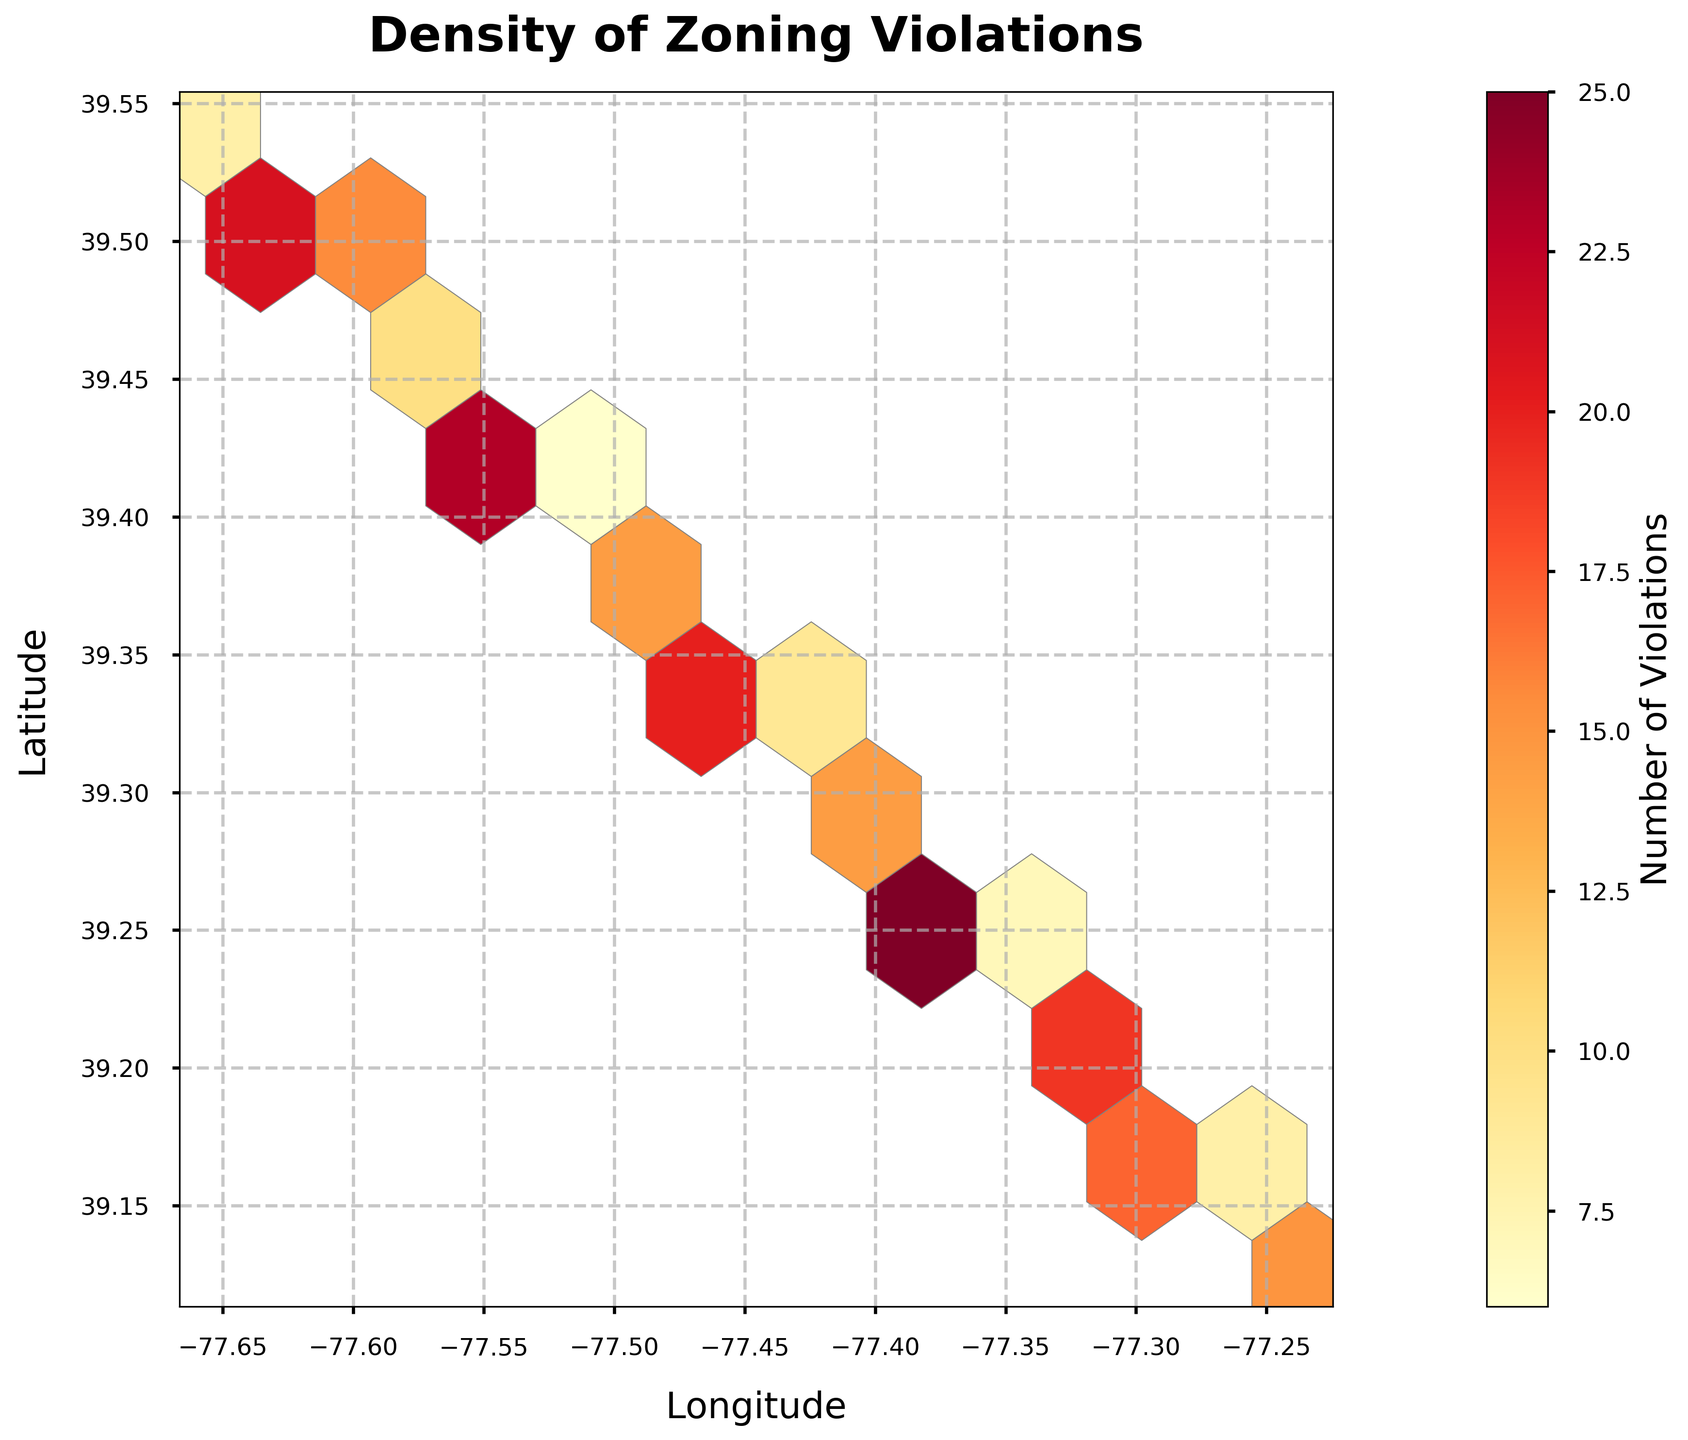What's the title of the figure? To determine the title, look at the top of the plot which typically contains this information. In this case, it states “Density of Zoning Violations”.
Answer: Density of Zoning Violations What do the colors in the hexagons represent? The color intensity in each hexagon indicates the number of zoning violations reported in a specific area. Areas with a higher density of violations will be represented with darker colors, according to the color map used, 'YlOrRd'.
Answer: Number of Violations What's the maximum density of zoning violations observed? By looking at the color bar, you can observe the correlation between color and number of violations. Identify the darkest hexagon and match it with the value on the color bar.
Answer: 25 Which coordinate has the highest number of violations? Locate the darkest hexagon on the plot, then check its corresponding coordinates (latitude and longitude). This hexagon represents the area with the highest number of violations.
Answer: (39.2556, -77.3678) What is the average number of violations in the darkest hexbin? Firstly, identify the darkest hexbin which correlates with the highest number of violations (25). Since it's a single value, the average is simply that value itself.
Answer: 25 How do the number of violations change as you move from west to east in the county? To understand the trend, observe the plot horizontally from left (west) to right (east). Note whether the color intensity increases, decreases, or shows no clear trend.
Answer: Varies; some regions have high, and some have low densities Do any specific areas show consistently low numbers of violations? Scan the plot for areas with lighter colors. Areas with consistently light hexagons showcase regions with low violations.
Answer: Yes What is the approximate range of latitudes covered in the plot? Review the y-axis limits to determine the minimum and maximum latitude values presented in the plot. This gives an approximate range of latitudes.
Answer: ~39.12 to ~39.54 How are most of the areas within the county in terms of zoning violations? Observe the overall color distribution in the plot. If most areas are lighter, violations are generally low; if darker, violations are high.
Answer: Generally moderate Which area should city planners focus on for improving zoning laws based on the plot? Identify regions with the darkest hexagons since they denote the highest number of violations. These regions would benefit most from intervention and regulation improvement.
Answer: Around (39.2556, -77.3678) 